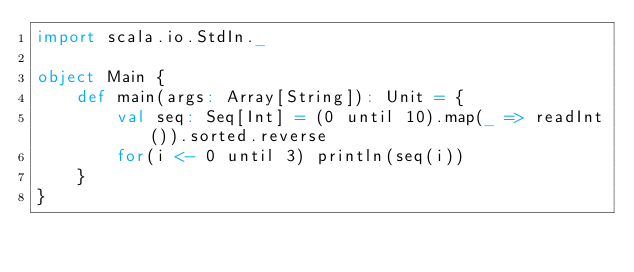<code> <loc_0><loc_0><loc_500><loc_500><_Scala_>import scala.io.StdIn._

object Main {
    def main(args: Array[String]): Unit = { 
        val seq: Seq[Int] = (0 until 10).map(_ => readInt()).sorted.reverse
        for(i <- 0 until 3) println(seq(i))
    }   
}</code> 